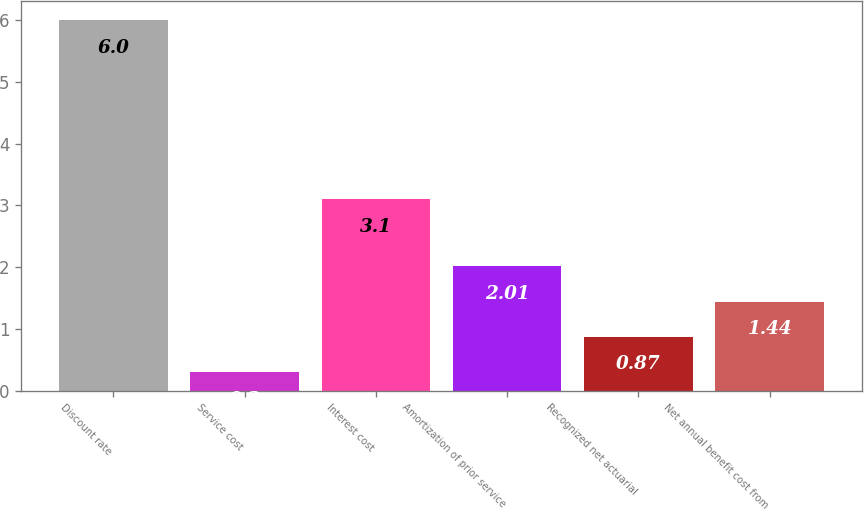Convert chart to OTSL. <chart><loc_0><loc_0><loc_500><loc_500><bar_chart><fcel>Discount rate<fcel>Service cost<fcel>Interest cost<fcel>Amortization of prior service<fcel>Recognized net actuarial<fcel>Net annual benefit cost from<nl><fcel>6<fcel>0.3<fcel>3.1<fcel>2.01<fcel>0.87<fcel>1.44<nl></chart> 